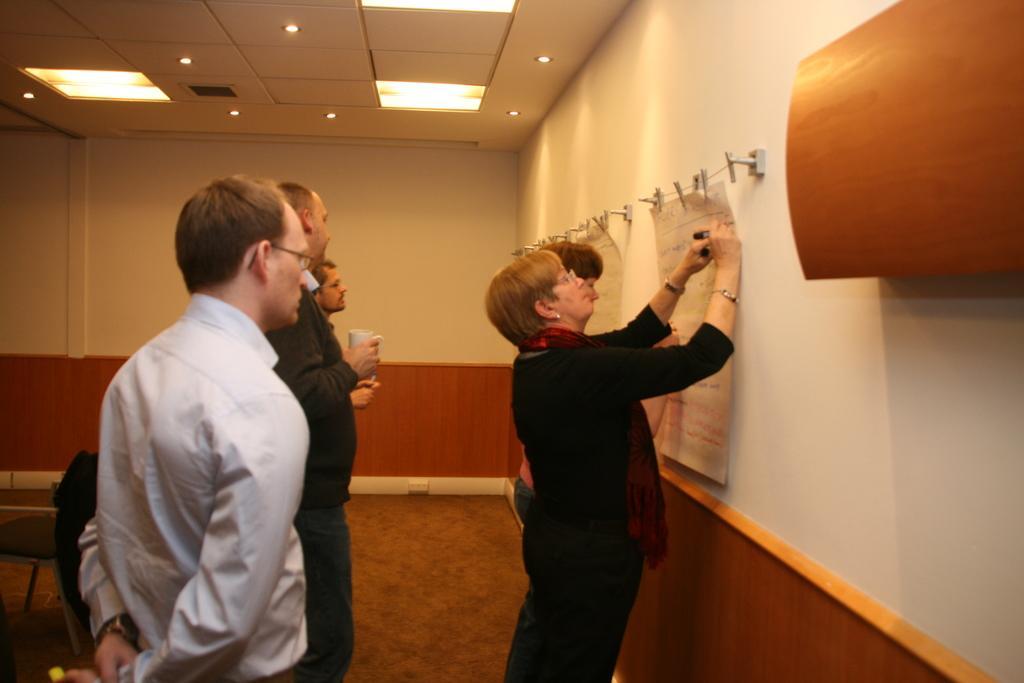Could you give a brief overview of what you see in this image? In this image I can see there are few persons standing in front of the wall and on the right side I can see the wall and I can see a woman is fixing the paper to the wall 